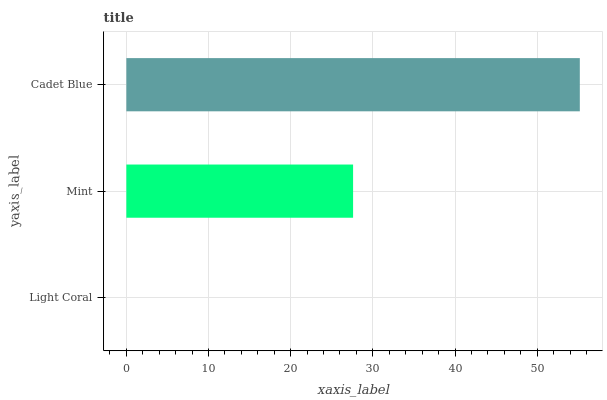Is Light Coral the minimum?
Answer yes or no. Yes. Is Cadet Blue the maximum?
Answer yes or no. Yes. Is Mint the minimum?
Answer yes or no. No. Is Mint the maximum?
Answer yes or no. No. Is Mint greater than Light Coral?
Answer yes or no. Yes. Is Light Coral less than Mint?
Answer yes or no. Yes. Is Light Coral greater than Mint?
Answer yes or no. No. Is Mint less than Light Coral?
Answer yes or no. No. Is Mint the high median?
Answer yes or no. Yes. Is Mint the low median?
Answer yes or no. Yes. Is Cadet Blue the high median?
Answer yes or no. No. Is Light Coral the low median?
Answer yes or no. No. 